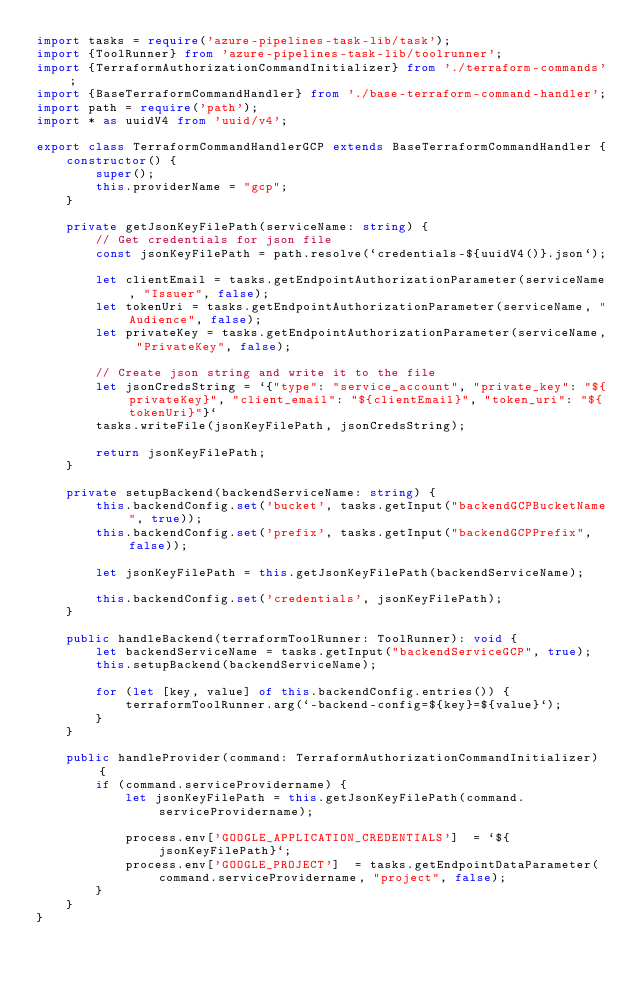<code> <loc_0><loc_0><loc_500><loc_500><_TypeScript_>import tasks = require('azure-pipelines-task-lib/task');
import {ToolRunner} from 'azure-pipelines-task-lib/toolrunner';
import {TerraformAuthorizationCommandInitializer} from './terraform-commands';
import {BaseTerraformCommandHandler} from './base-terraform-command-handler';
import path = require('path');
import * as uuidV4 from 'uuid/v4';

export class TerraformCommandHandlerGCP extends BaseTerraformCommandHandler {
    constructor() {
        super();
        this.providerName = "gcp";
    }

    private getJsonKeyFilePath(serviceName: string) {
        // Get credentials for json file
        const jsonKeyFilePath = path.resolve(`credentials-${uuidV4()}.json`);

        let clientEmail = tasks.getEndpointAuthorizationParameter(serviceName, "Issuer", false);
        let tokenUri = tasks.getEndpointAuthorizationParameter(serviceName, "Audience", false);
        let privateKey = tasks.getEndpointAuthorizationParameter(serviceName, "PrivateKey", false);

        // Create json string and write it to the file
        let jsonCredsString = `{"type": "service_account", "private_key": "${privateKey}", "client_email": "${clientEmail}", "token_uri": "${tokenUri}"}`
        tasks.writeFile(jsonKeyFilePath, jsonCredsString);

        return jsonKeyFilePath;
    }

    private setupBackend(backendServiceName: string) {
        this.backendConfig.set('bucket', tasks.getInput("backendGCPBucketName", true));
        this.backendConfig.set('prefix', tasks.getInput("backendGCPPrefix", false));

        let jsonKeyFilePath = this.getJsonKeyFilePath(backendServiceName);

        this.backendConfig.set('credentials', jsonKeyFilePath);
    }

    public handleBackend(terraformToolRunner: ToolRunner): void {
        let backendServiceName = tasks.getInput("backendServiceGCP", true);
        this.setupBackend(backendServiceName);

        for (let [key, value] of this.backendConfig.entries()) {
            terraformToolRunner.arg(`-backend-config=${key}=${value}`);
        }
    }

    public handleProvider(command: TerraformAuthorizationCommandInitializer) {
        if (command.serviceProvidername) {
            let jsonKeyFilePath = this.getJsonKeyFilePath(command.serviceProvidername);

            process.env['GOOGLE_APPLICATION_CREDENTIALS']  = `${jsonKeyFilePath}`;
            process.env['GOOGLE_PROJECT']  = tasks.getEndpointDataParameter(command.serviceProvidername, "project", false);            
        }
    }
}</code> 